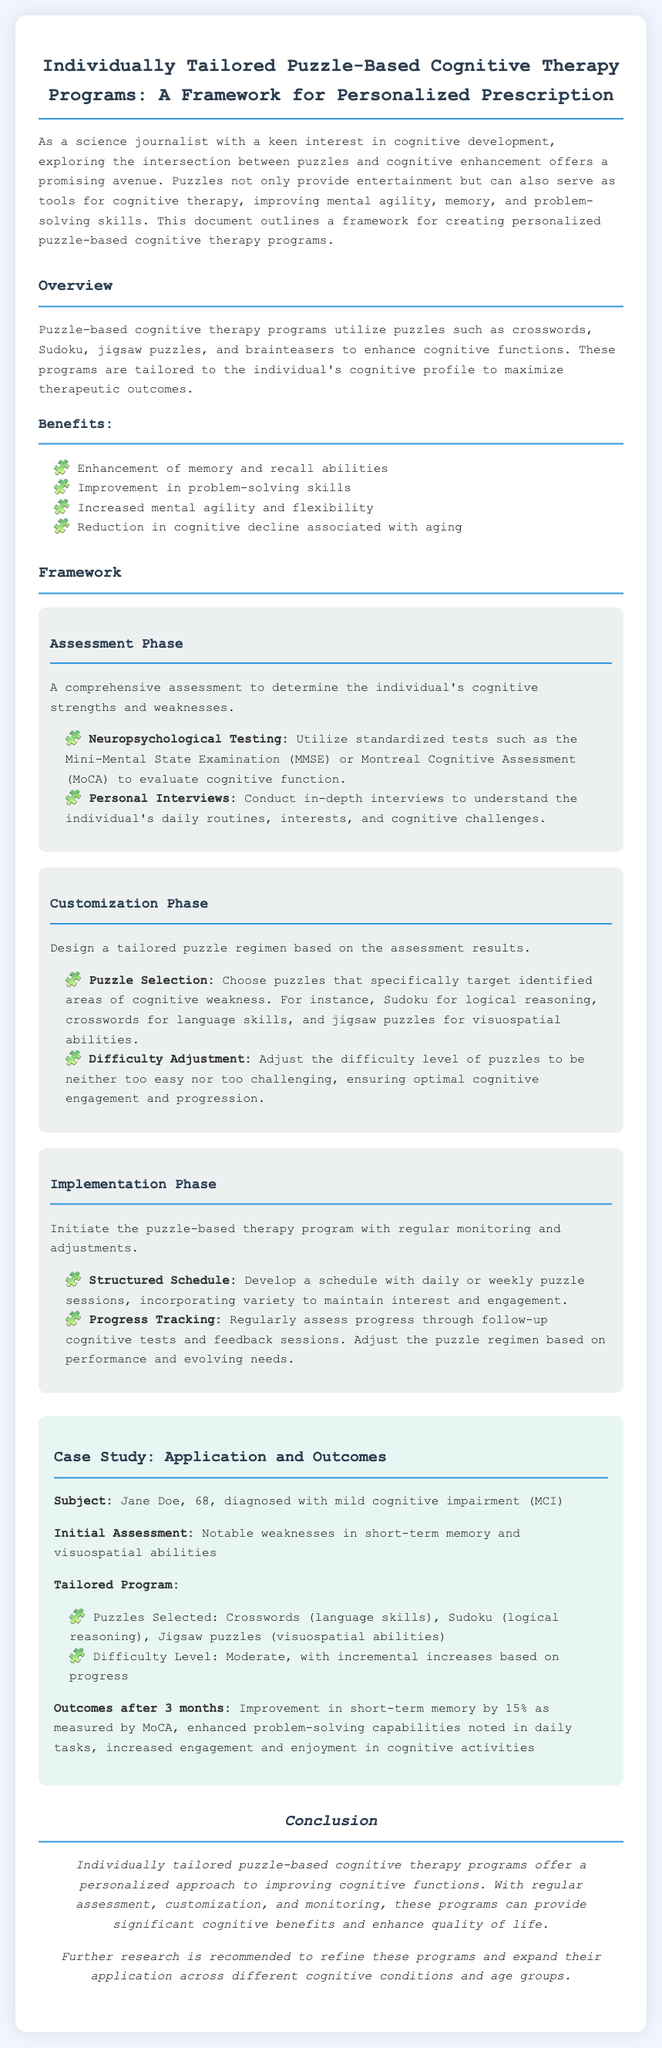What is the main purpose of puzzle-based cognitive therapy programs? The document states that these programs are designed to enhance cognitive functions by utilizing puzzles tailored to the individual's cognitive profile.
Answer: enhance cognitive functions What age group was the subject of the case study? The case study mentions that Jane Doe is 68 years old, highlighting her age group related to cognitive impairment.
Answer: 68 What are two types of puzzles mentioned in the tailored program for Jane Doe? The document lists crosswords and Sudoku as part of the tailored puzzle regimen designed for the subject.
Answer: crosswords, Sudoku What percentage improvement in short-term memory was observed after 3 months? The outcomes section indicates that there was a 15% improvement in short-term memory for Jane Doe after the prescribed therapy regimen.
Answer: 15% What is the first phase of the puzzle-based cognitive therapy framework? The document outlines the framework and identifies the assessment phase as the first step in creating a personalized therapy program.
Answer: Assessment Phase How many cognitive functions does the overview mention enhancing? The overview section outlines four cognitive functions mentioned as benefits of the therapy program, which signifies its multifaceted approach.
Answer: four What format is the document presented in? The structure and sections of the content indicate it is a Prescription document specifically designed to outline a framework for therapy programs.
Answer: Prescription What cognitive challenge did Jane Doe have notably in the initial assessment? The initial assessment indicates that Jane Doe had weaknesses in short-term memory, which was a focus for her tailored program.
Answer: short-term memory What is recommended for further development at the conclusion? The conclusion suggests that further research is needed to refine the puzzle-based cognitive therapy programs and broaden their applicability.
Answer: further research 